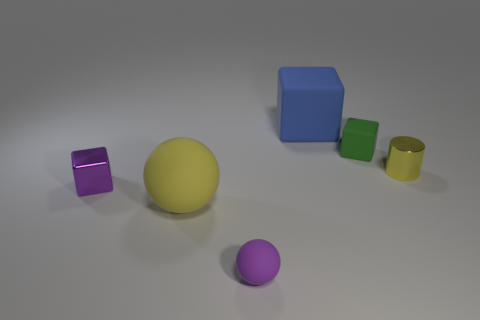What is the color of the other big object that is the same shape as the green thing?
Your answer should be very brief. Blue. Does the large ball have the same color as the tiny rubber thing that is left of the small green matte object?
Your answer should be compact. No. There is a rubber object that is both in front of the large rubber block and behind the small yellow cylinder; what is its shape?
Your response must be concise. Cube. Is the number of tiny gray rubber cubes less than the number of shiny things?
Your answer should be very brief. Yes. Is there a large yellow matte sphere?
Ensure brevity in your answer.  Yes. How many other objects are there of the same size as the green object?
Provide a succinct answer. 3. Are the yellow ball and the large object that is behind the purple metal thing made of the same material?
Give a very brief answer. Yes. Are there an equal number of large yellow rubber spheres to the right of the tiny yellow object and small yellow metal objects that are left of the green rubber cube?
Offer a terse response. Yes. What is the large sphere made of?
Offer a very short reply. Rubber. There is a metal object that is the same size as the metal cylinder; what color is it?
Your answer should be very brief. Purple. 